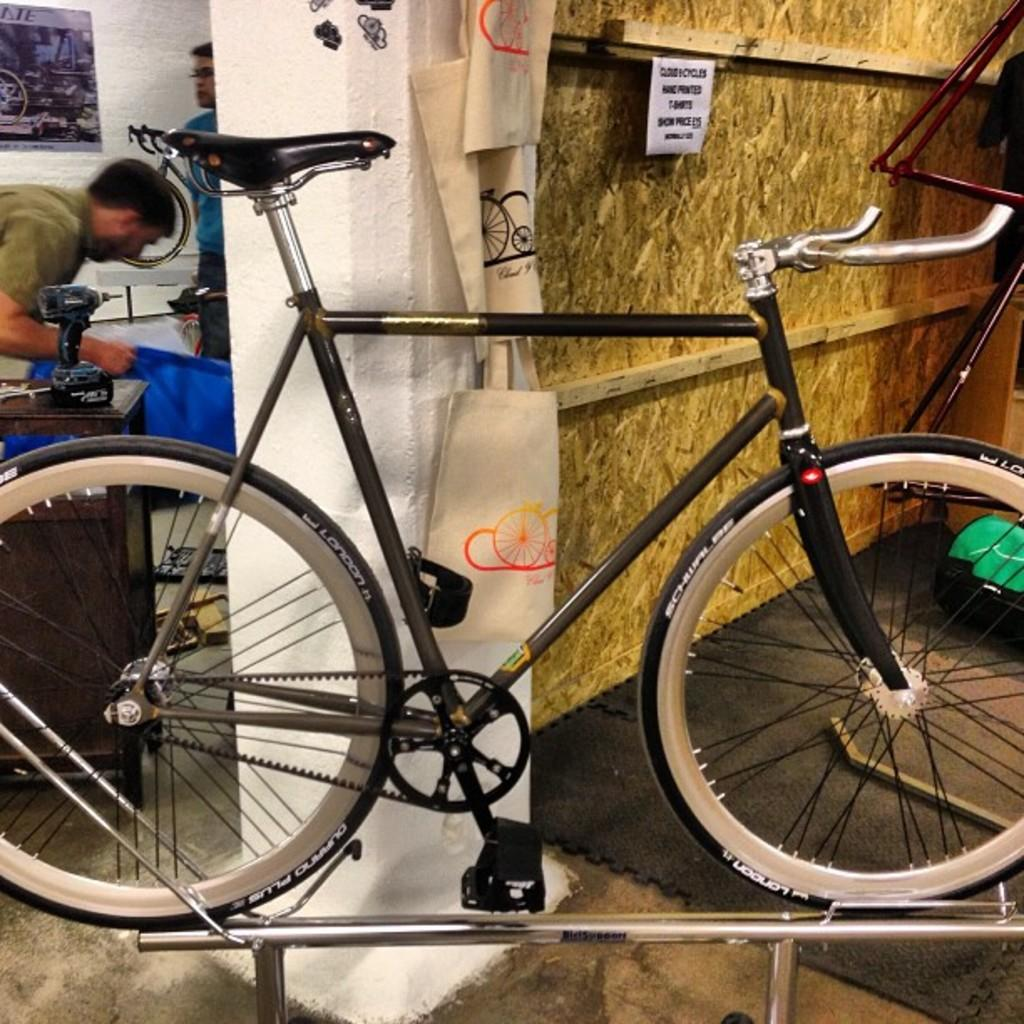What is placed on the road in the image? There is a bicycle placed on the road in the image. What can be seen in the background of the image? There are people and objects visible in the background of the image. What items are visible in the image besides the bicycle? There are bags visible in the image. What is on the wall in the image? There are posters on the wall in the image. What year is depicted on the bicycle in the image? There is no year visible on the bicycle in the image. Can you describe the neck of the person in the image? There is no person visible in the image; only a bicycle, bags, posters, and people and objects in the background are present. 